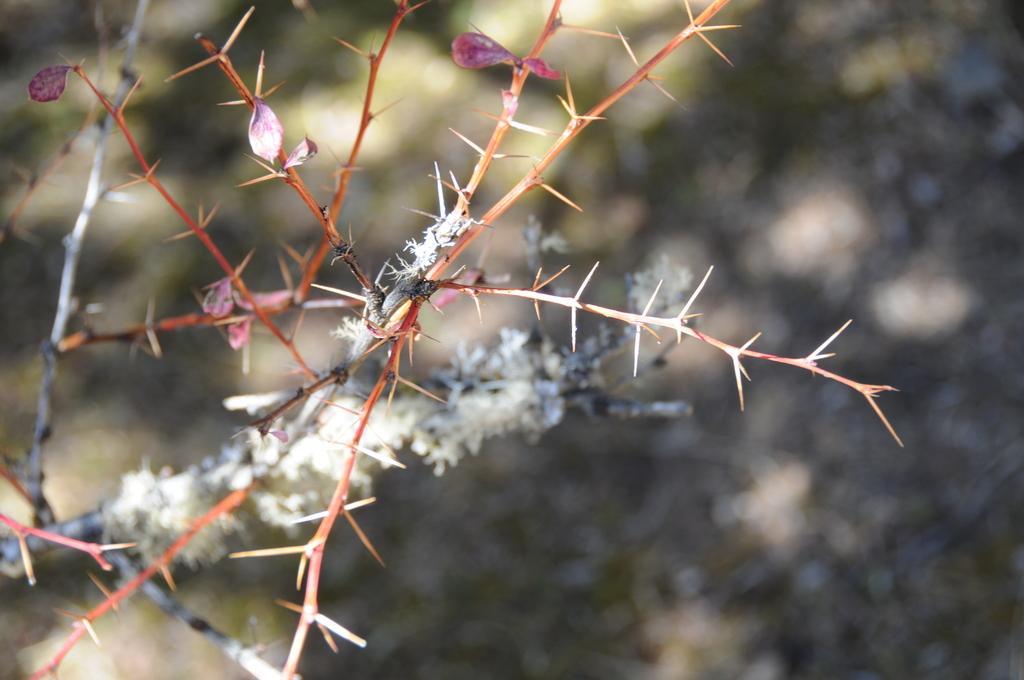Please provide a concise description of this image. In the image there are stems with thorns. And also there are white color object on the stem. Behind the stems there is a blur background. 